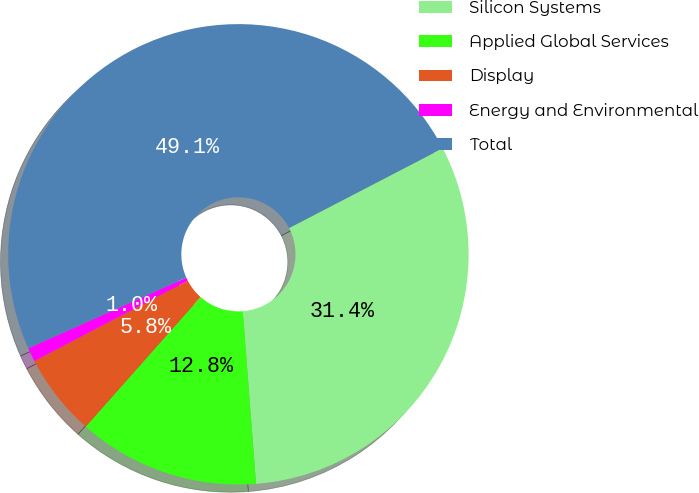<chart> <loc_0><loc_0><loc_500><loc_500><pie_chart><fcel>Silicon Systems<fcel>Applied Global Services<fcel>Display<fcel>Energy and Environmental<fcel>Total<nl><fcel>31.4%<fcel>12.76%<fcel>5.79%<fcel>0.98%<fcel>49.07%<nl></chart> 